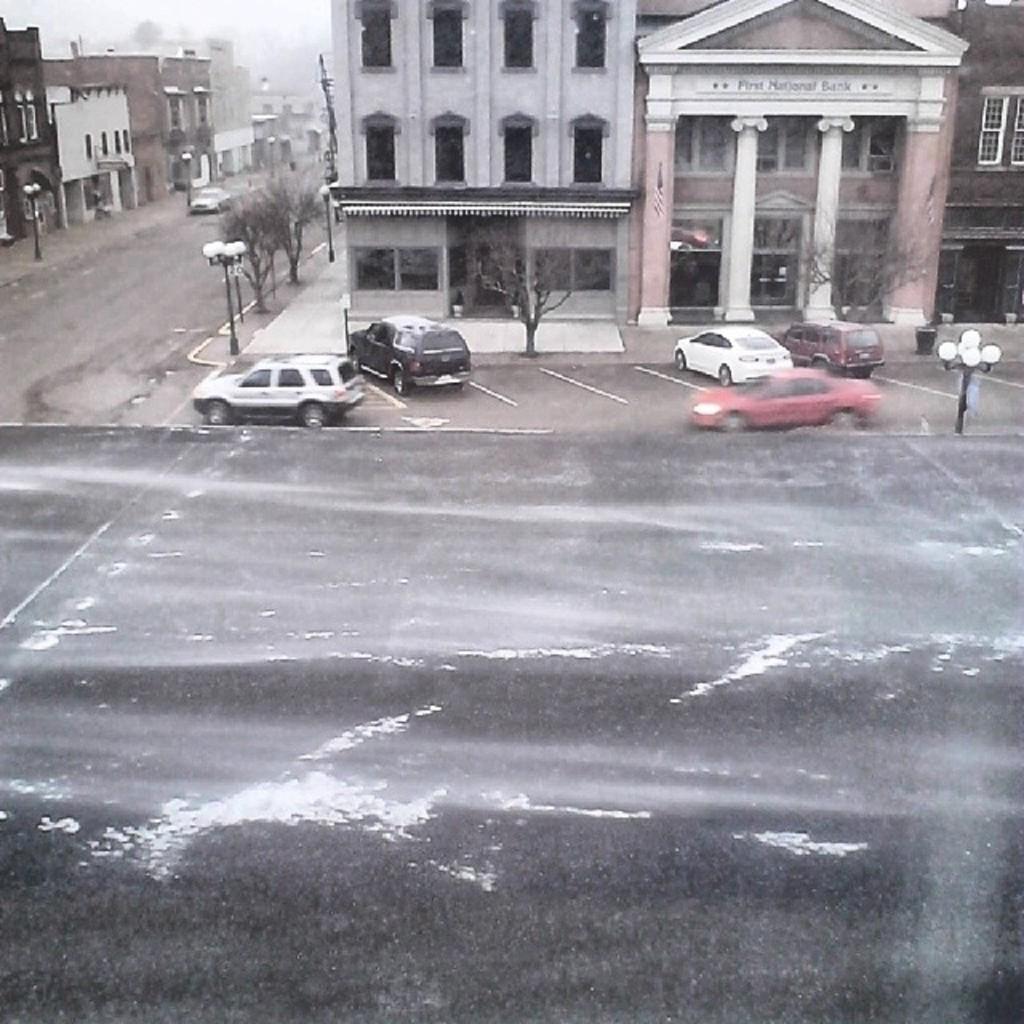Describe this image in one or two sentences. In this picture we can see a building with windows,sun shade,pillars and in front of the building there is road and on the road we can see cars and we have many buildings and here this is sky. 